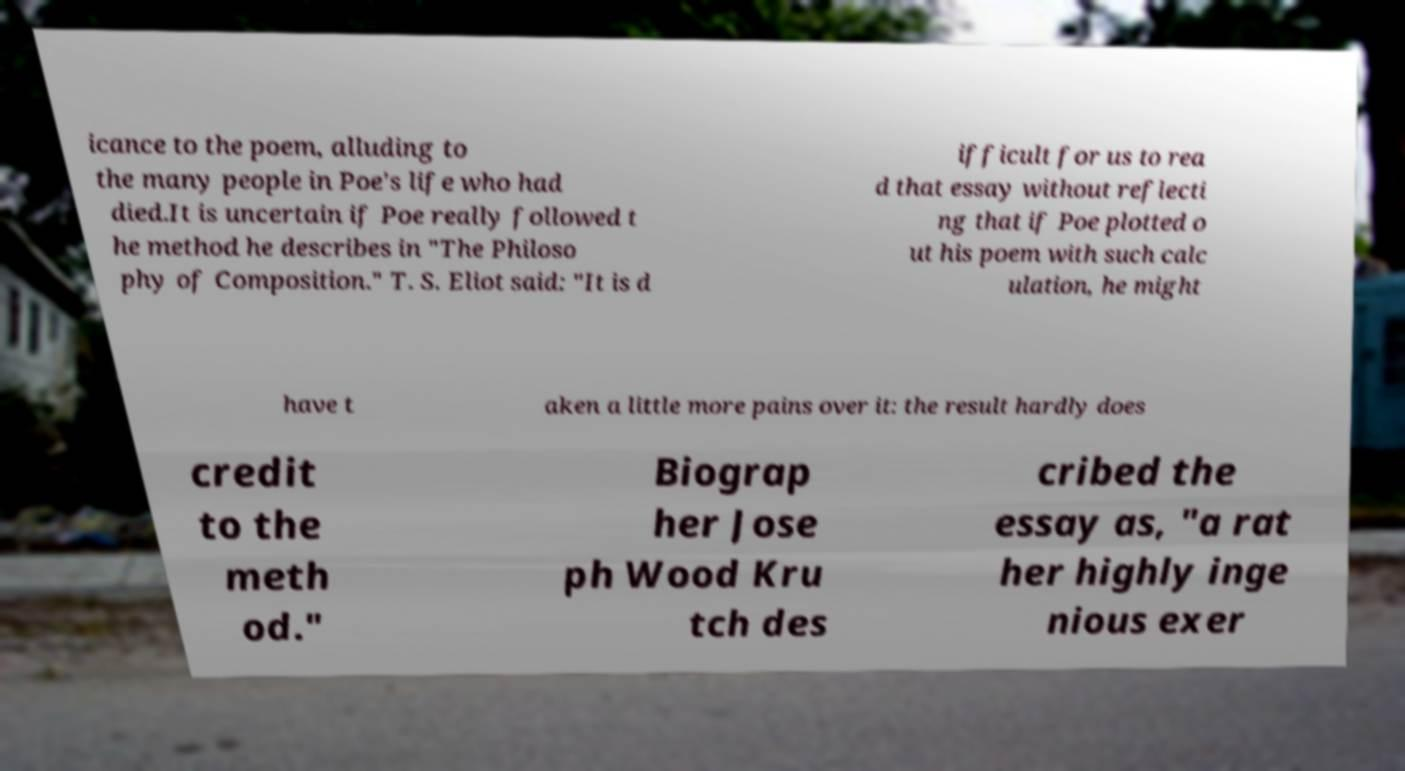For documentation purposes, I need the text within this image transcribed. Could you provide that? icance to the poem, alluding to the many people in Poe's life who had died.It is uncertain if Poe really followed t he method he describes in "The Philoso phy of Composition." T. S. Eliot said: "It is d ifficult for us to rea d that essay without reflecti ng that if Poe plotted o ut his poem with such calc ulation, he might have t aken a little more pains over it: the result hardly does credit to the meth od." Biograp her Jose ph Wood Kru tch des cribed the essay as, "a rat her highly inge nious exer 